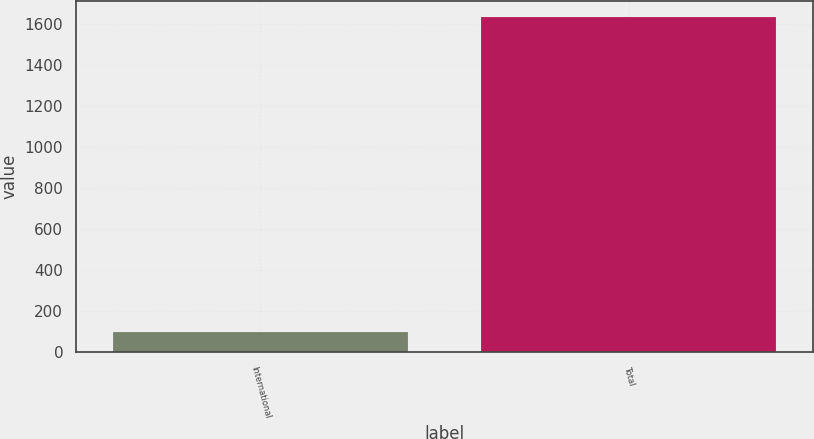Convert chart. <chart><loc_0><loc_0><loc_500><loc_500><bar_chart><fcel>International<fcel>Total<nl><fcel>95<fcel>1634<nl></chart> 